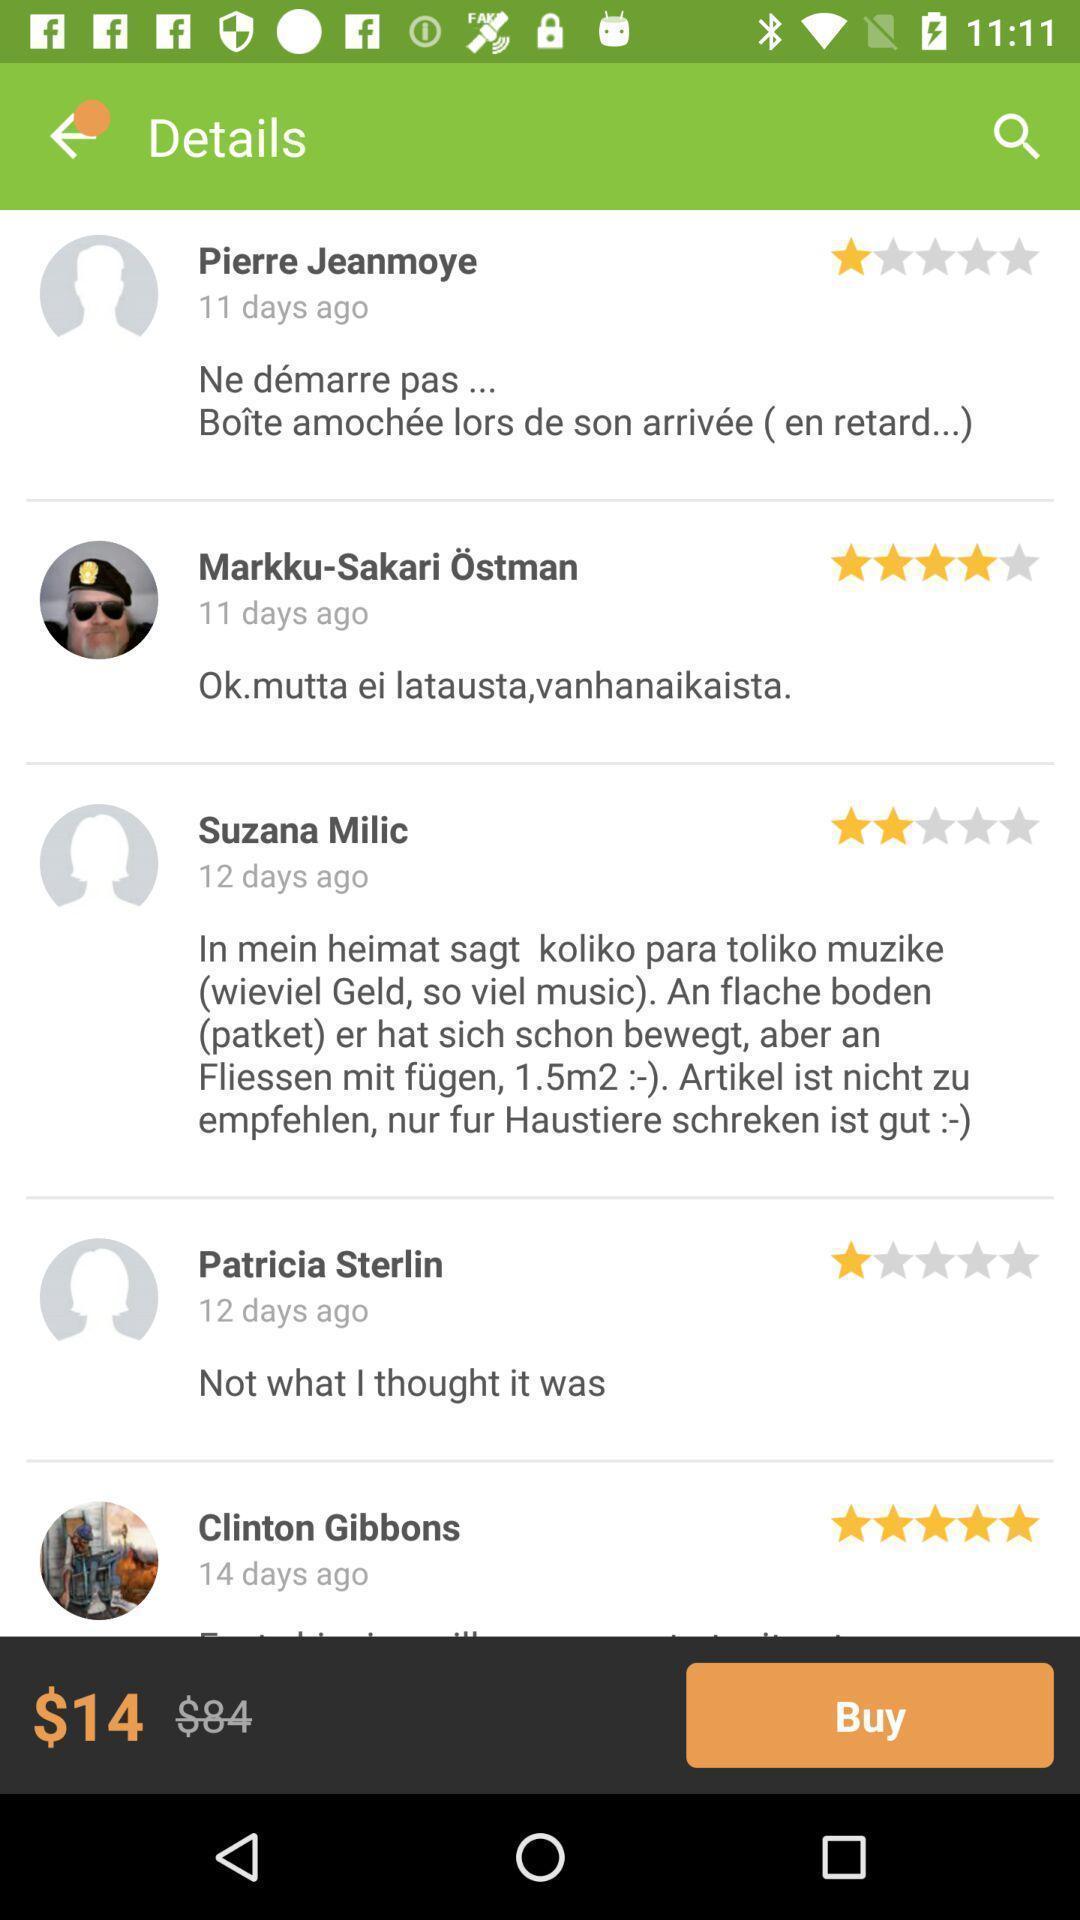Provide a textual representation of this image. Page with price and comments in shopping application. 